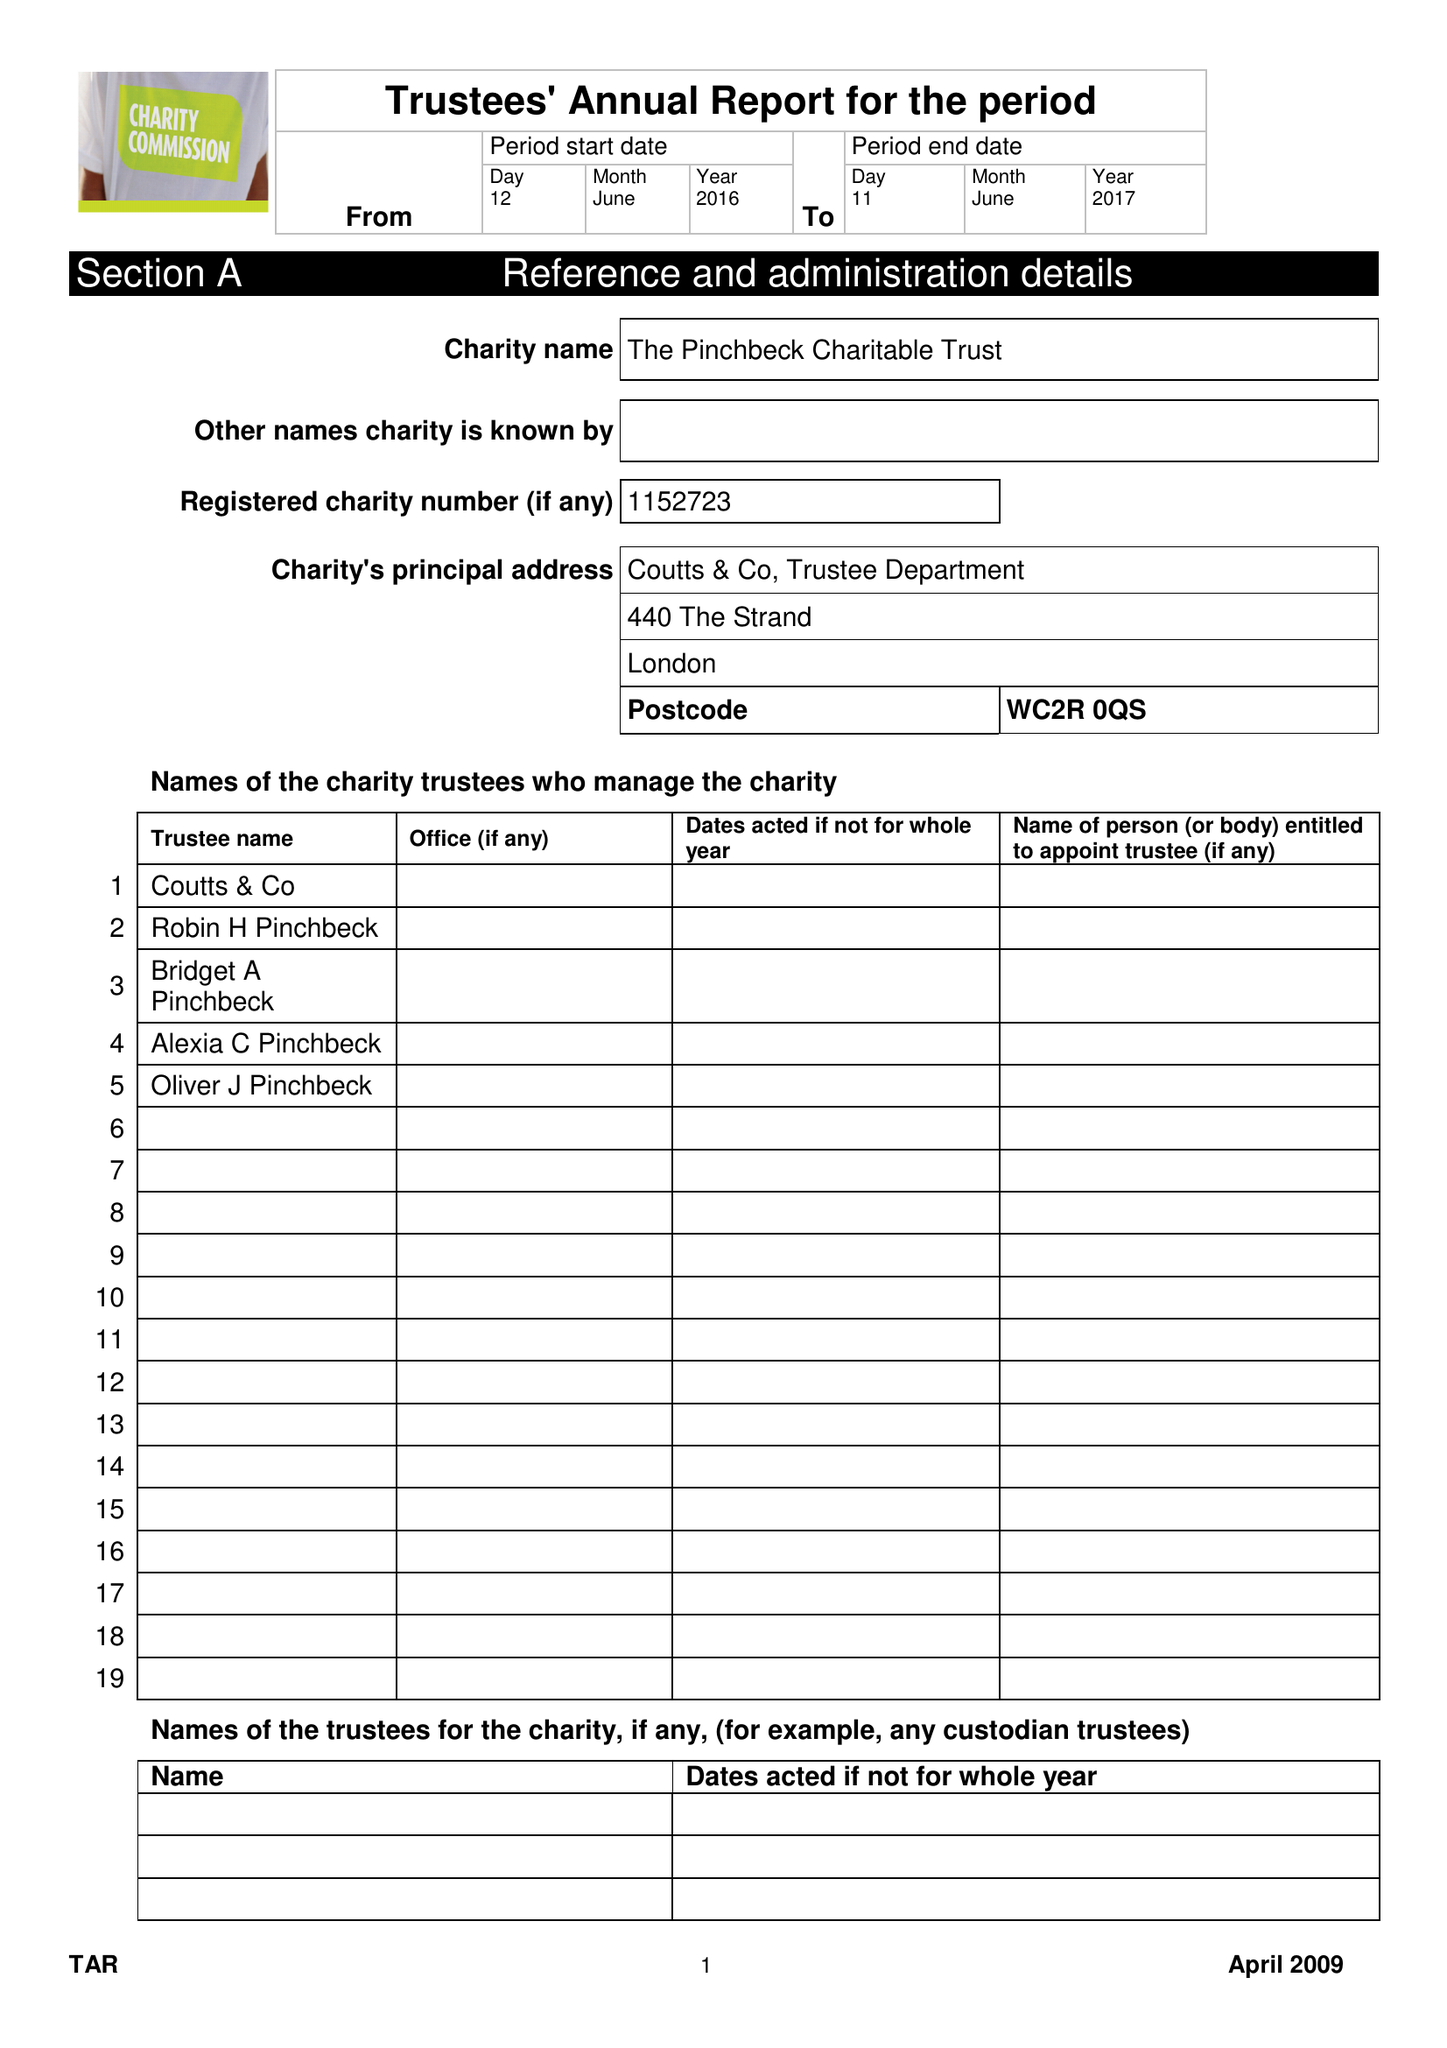What is the value for the report_date?
Answer the question using a single word or phrase. 2017-06-11 